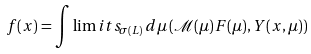<formula> <loc_0><loc_0><loc_500><loc_500>f ( x ) = \int \lim i t s _ { \sigma ( L ) } \, d \mu \, ( \mathcal { M } ( \mu ) F ( \mu ) , Y ( x , \mu ) )</formula> 